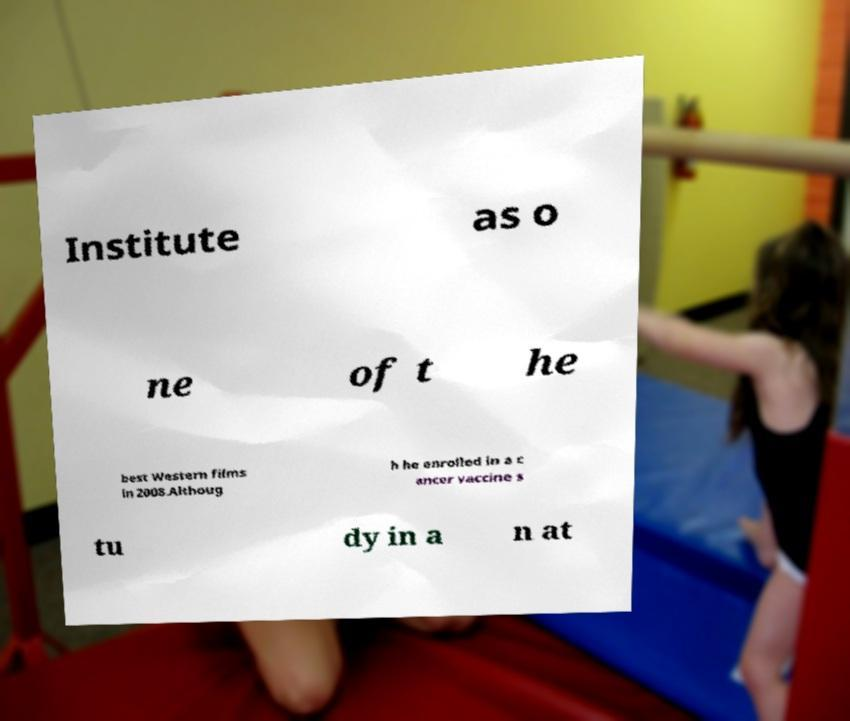Could you extract and type out the text from this image? Institute as o ne of t he best Western films in 2008.Althoug h he enrolled in a c ancer vaccine s tu dy in a n at 